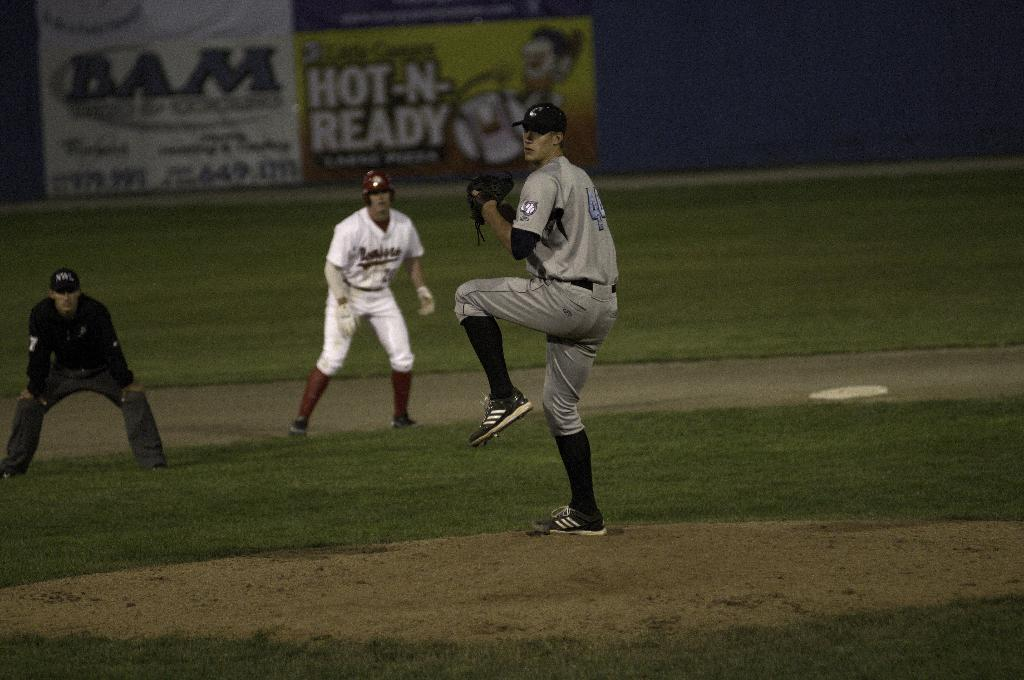<image>
Give a short and clear explanation of the subsequent image. A pitcher in a baseball stadium, that is sponsored in part by little Caesars. 